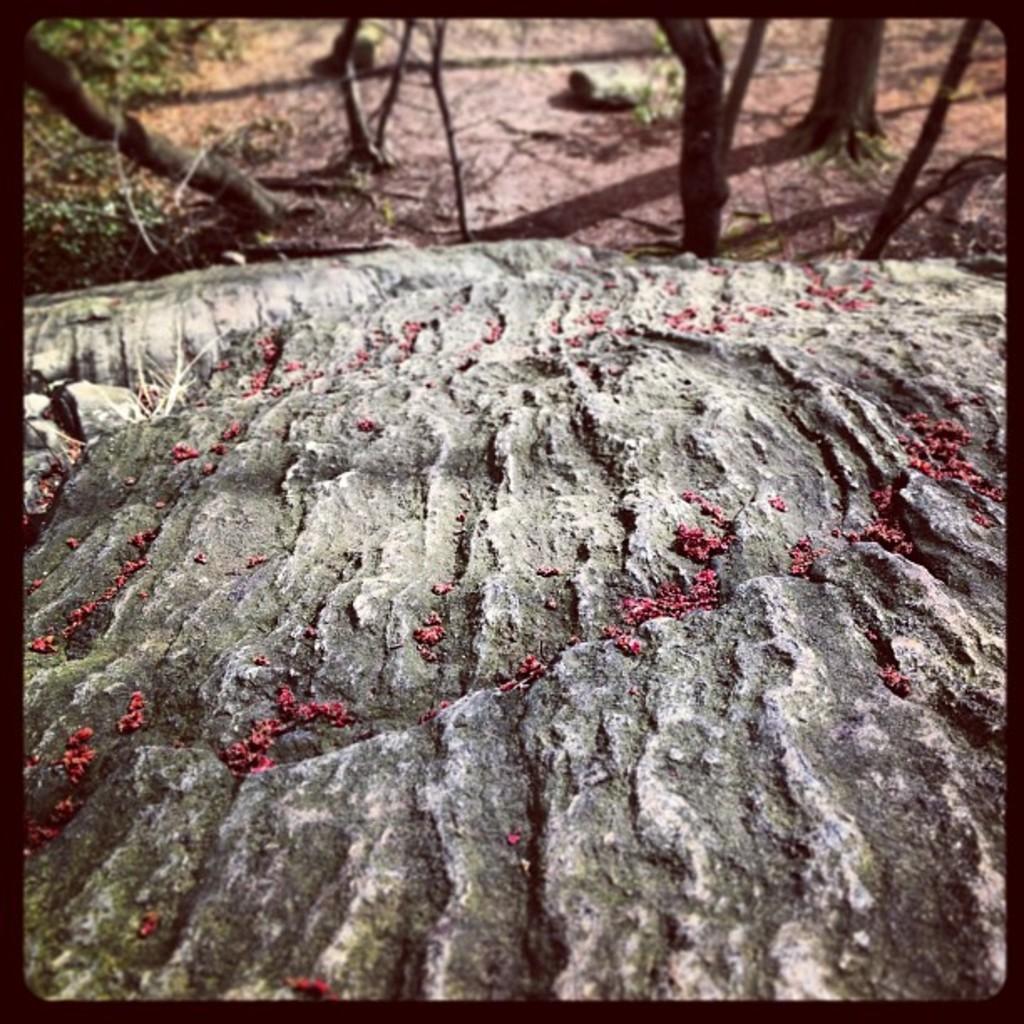Describe this image in one or two sentences. At the bottom of this image, there are seeds on the rock. In the background, there are trees, a rock, plants and sticks on the ground. 